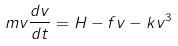<formula> <loc_0><loc_0><loc_500><loc_500>m v \frac { d v } { d t } = H - f v - k v ^ { 3 }</formula> 